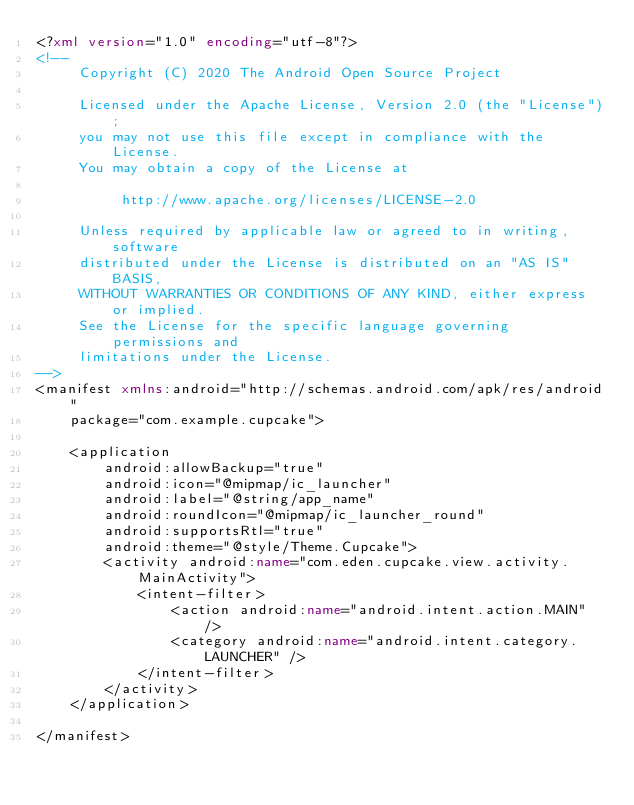<code> <loc_0><loc_0><loc_500><loc_500><_XML_><?xml version="1.0" encoding="utf-8"?>
<!--
     Copyright (C) 2020 The Android Open Source Project

     Licensed under the Apache License, Version 2.0 (the "License");
     you may not use this file except in compliance with the License.
     You may obtain a copy of the License at

          http://www.apache.org/licenses/LICENSE-2.0

     Unless required by applicable law or agreed to in writing, software
     distributed under the License is distributed on an "AS IS" BASIS,
     WITHOUT WARRANTIES OR CONDITIONS OF ANY KIND, either express or implied.
     See the License for the specific language governing permissions and
     limitations under the License.
-->
<manifest xmlns:android="http://schemas.android.com/apk/res/android"
    package="com.example.cupcake">

    <application
        android:allowBackup="true"
        android:icon="@mipmap/ic_launcher"
        android:label="@string/app_name"
        android:roundIcon="@mipmap/ic_launcher_round"
        android:supportsRtl="true"
        android:theme="@style/Theme.Cupcake">
        <activity android:name="com.eden.cupcake.view.activity.MainActivity">
            <intent-filter>
                <action android:name="android.intent.action.MAIN" />
                <category android:name="android.intent.category.LAUNCHER" />
            </intent-filter>
        </activity>
    </application>

</manifest></code> 